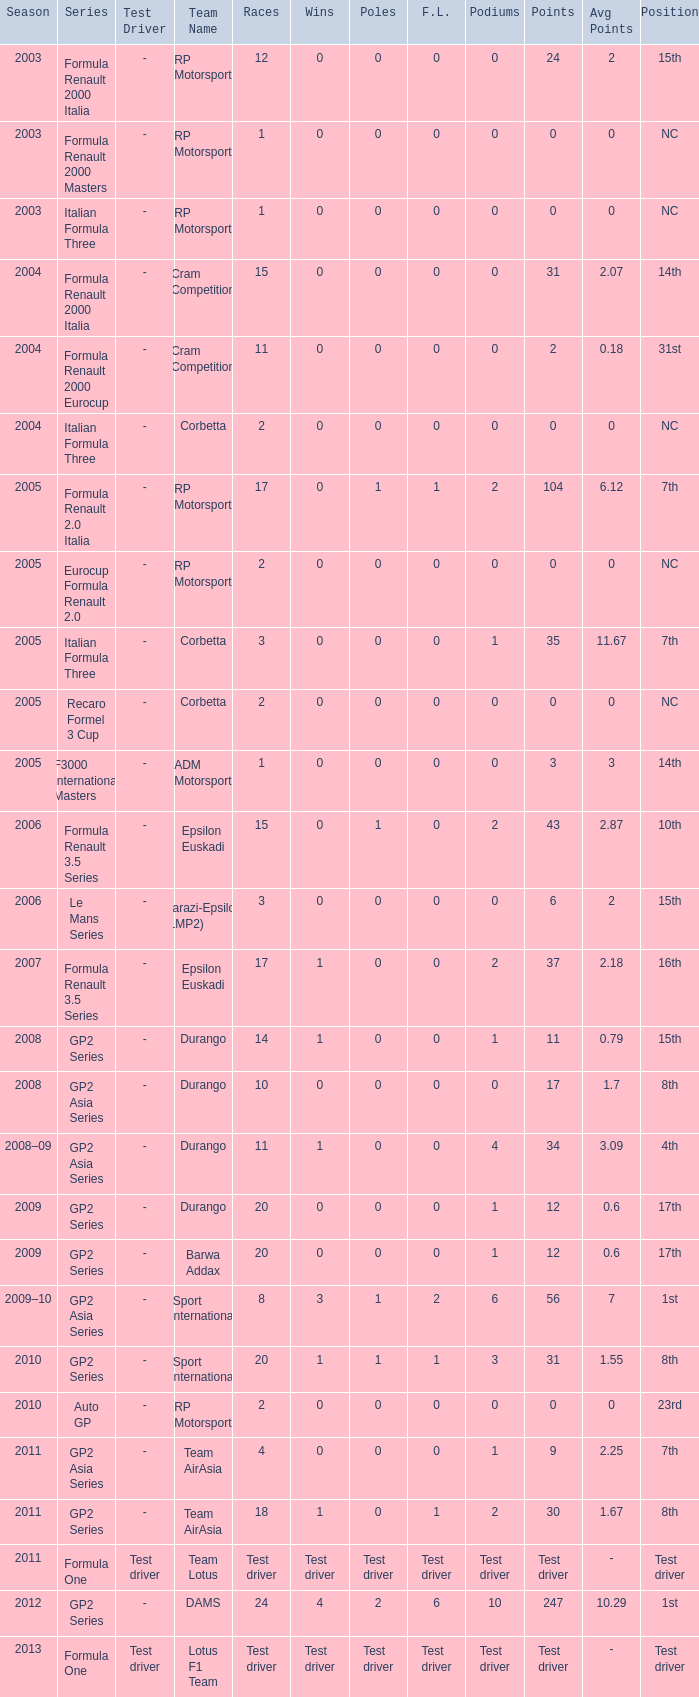What is the number of wins with a 0 F.L., 0 poles, a position of 7th, and 35 points? 0.0. 